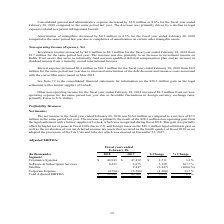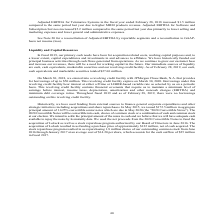According to Calamp's financial document, What was the main reason for the increase in net income in the fiscal year ended February 28, 2018? The increase is primarily the result of the $28.3 million non-operating gain from the legal settlement with a former supplier of LoJack, which was recognized during fiscal 2018.. The document states: "loss of $7.9 million in the same period last year. The increase is primarily the result of the $28.3 million non-operating gain from the legal settlem..." Also, What was the Adjusted EBITDA for Telematics Systems in 2018? According to the financial document, 48,943 (in thousands). The relevant text states: "17 $ Change % Change Segment Telematics Systems $ 48,943 $ 47,432 $ 1,511 3.2% Software & Subscription Services 8,233 3,075 5,158 167.7% Satellite - 2,447 (..." Also, What was the Adjusted EBITDA for Telematics Systems in 2017? According to the financial document, 47,432 (in thousands). The relevant text states: "ge % Change Segment Telematics Systems $ 48,943 $ 47,432 $ 1,511 3.2% Software & Subscription Services 8,233 3,075 5,158 167.7% Satellite - 2,447 (2,447) (1..." Also, can you calculate: What was the total Adjusted EBITDA for Telematics Systems and Software & Subscription Services in 2018? Based on the calculation: (48,943+8,233), the result is 57176 (in thousands). This is based on the information: "17 $ Change % Change Segment Telematics Systems $ 48,943 $ 47,432 $ 1,511 3.2% Software & Subscription Services 8,233 3,075 5,158 167.7% Satellite - 2,447 ( 432 $ 1,511 3.2% Software & Subscription Se..." The key data points involved are: 48,943, 8,233. Also, can you calculate: What was the total Adjusted EBITDA for Telematics Systems and Software & Subscription Services in 2017? Based on the calculation: (47,432+3,075), the result is 50507 (in thousands). This is based on the information: "1,511 3.2% Software & Subscription Services 8,233 3,075 5,158 167.7% Satellite - 2,447 (2,447) (100.0%) Corporate Expense (4,794) (3,586) (1,208) 33.7% Tot ge % Change Segment Telematics Systems $ 48,..." The key data points involved are: 3,075, 47,432. Also, can you calculate: What was the average corporate expense for both years, 2017 and 2018? To answer this question, I need to perform calculations using the financial data. The calculation is: (-4,794-3,586)/(2018-2017+1), which equals -4190 (in thousands). This is based on the information: "2,447 (2,447) (100.0%) Corporate Expense (4,794) (3,586) (1,208) 33.7% Total Adjusted EBITDA $ 52,382 $ 49,368 $ 3,014 6.1% llite - 2,447 (2,447) (100.0%) Corporate Expense (4,794) (3,586) (1,208) 33...." The key data points involved are: 3,586, 4,794. 